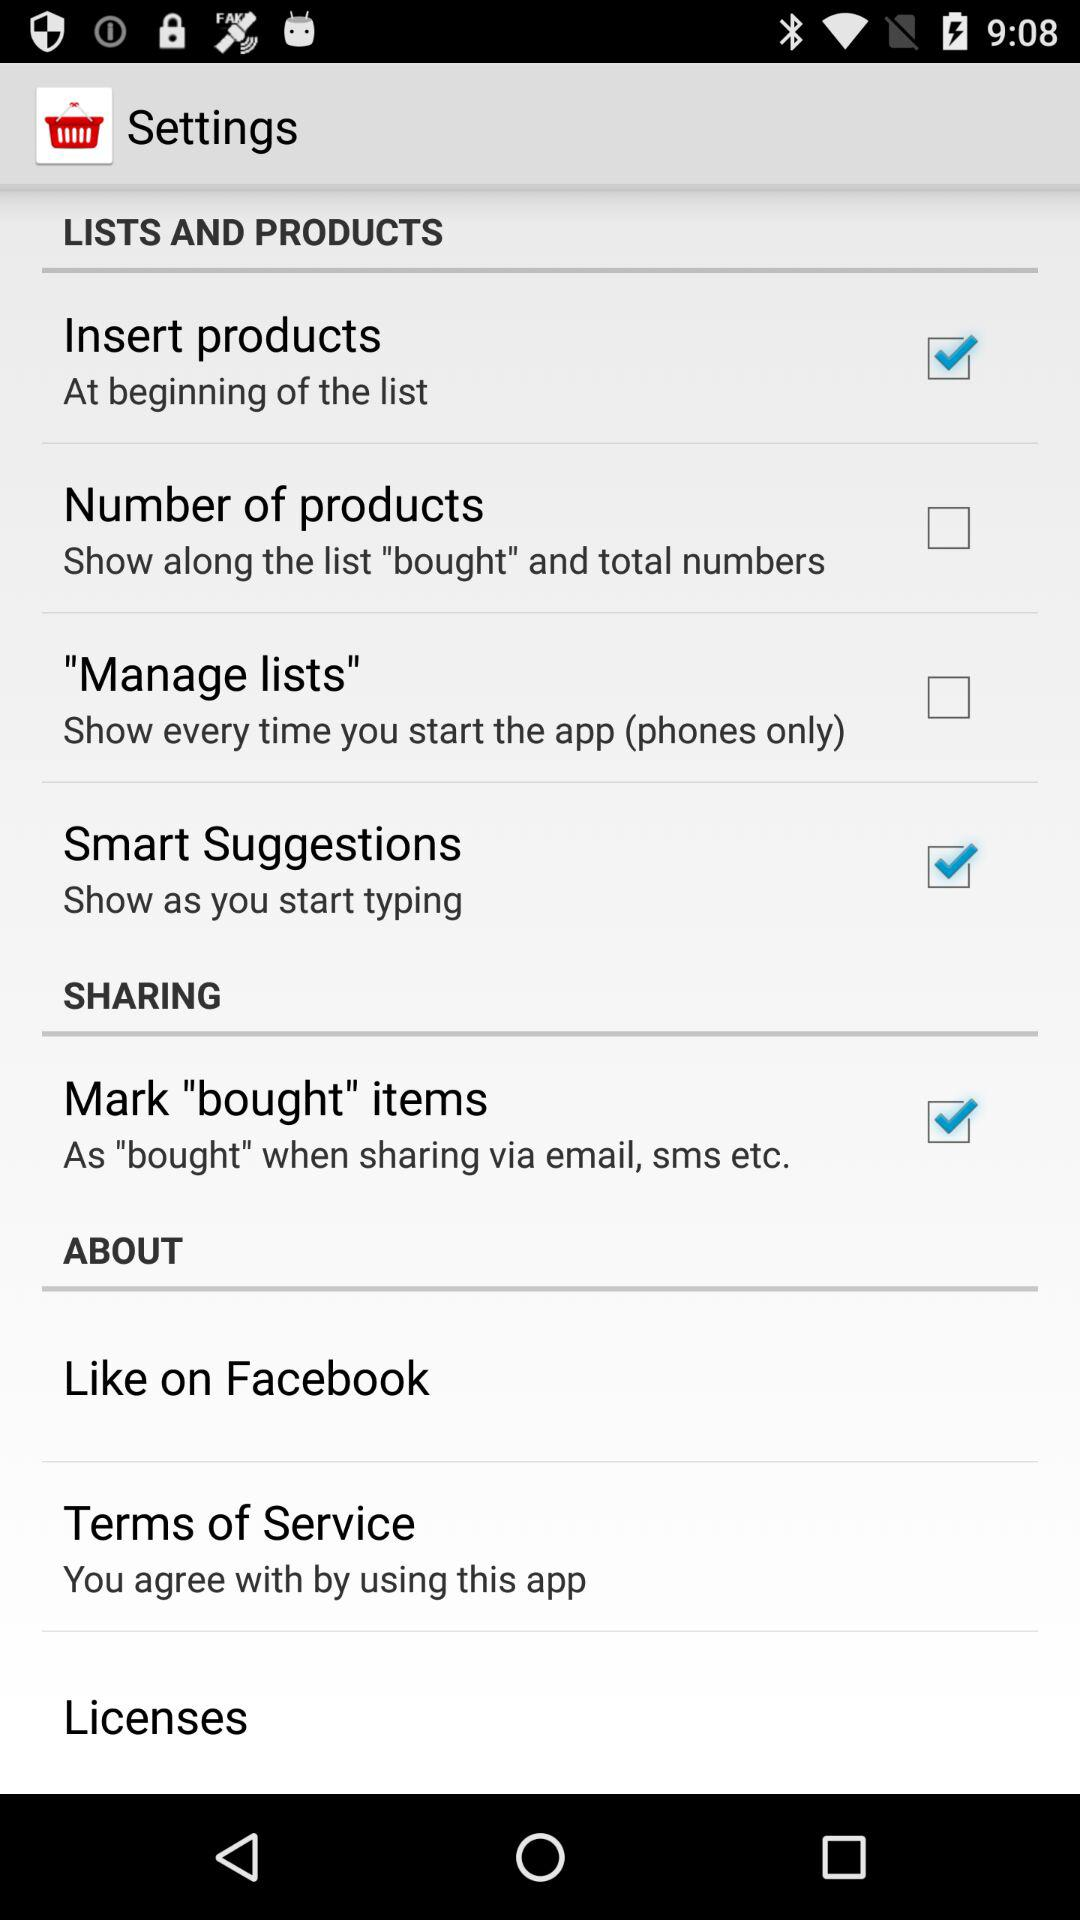What is the status of smart suggestions? The status is "on". 